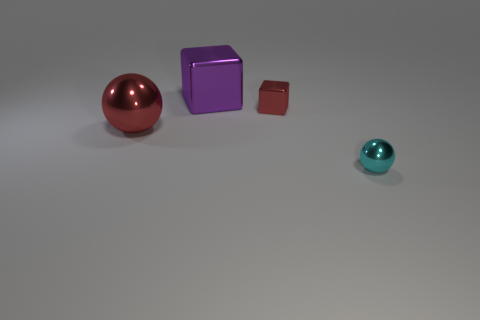What shape is the thing that is the same color as the small cube?
Keep it short and to the point. Sphere. How many other things are the same shape as the purple object?
Your answer should be very brief. 1. Is the color of the large metal block the same as the tiny thing on the left side of the cyan ball?
Your answer should be very brief. No. Is there any other thing that has the same material as the big cube?
Offer a very short reply. Yes. What shape is the red metallic thing that is behind the object that is left of the large purple thing?
Ensure brevity in your answer.  Cube. The metal thing that is the same color as the small metal block is what size?
Keep it short and to the point. Large. There is a large object behind the large red metallic thing; does it have the same shape as the big red object?
Give a very brief answer. No. Is the number of purple shiny things that are right of the small red metallic object greater than the number of big red balls that are behind the big shiny ball?
Give a very brief answer. No. There is a shiny thing left of the purple metallic block; what number of big red things are left of it?
Your response must be concise. 0. There is a object that is the same color as the tiny block; what is its material?
Offer a terse response. Metal. 